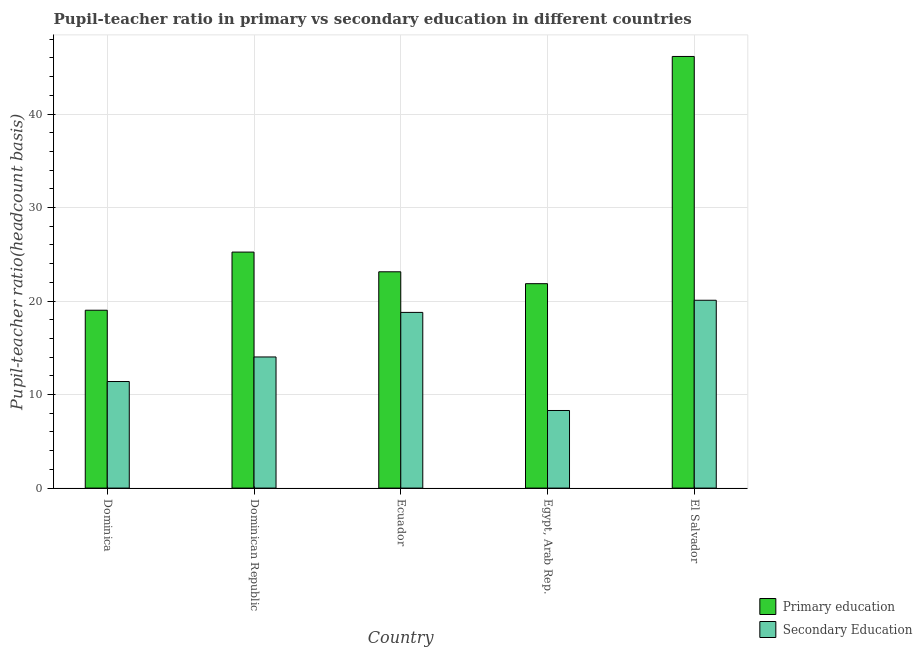How many groups of bars are there?
Provide a succinct answer. 5. Are the number of bars per tick equal to the number of legend labels?
Provide a short and direct response. Yes. How many bars are there on the 2nd tick from the left?
Ensure brevity in your answer.  2. How many bars are there on the 1st tick from the right?
Offer a very short reply. 2. What is the label of the 2nd group of bars from the left?
Provide a short and direct response. Dominican Republic. What is the pupil-teacher ratio in primary education in El Salvador?
Provide a short and direct response. 46.16. Across all countries, what is the maximum pupil-teacher ratio in primary education?
Offer a terse response. 46.16. Across all countries, what is the minimum pupil-teacher ratio in primary education?
Give a very brief answer. 19.02. In which country was the pupil-teacher ratio in primary education maximum?
Your answer should be compact. El Salvador. In which country was the pupil-teacher ratio in primary education minimum?
Ensure brevity in your answer.  Dominica. What is the total pupil teacher ratio on secondary education in the graph?
Give a very brief answer. 72.6. What is the difference between the pupil teacher ratio on secondary education in Dominica and that in El Salvador?
Make the answer very short. -8.69. What is the difference between the pupil teacher ratio on secondary education in Ecuador and the pupil-teacher ratio in primary education in Dominica?
Provide a succinct answer. -0.23. What is the average pupil teacher ratio on secondary education per country?
Make the answer very short. 14.52. What is the difference between the pupil teacher ratio on secondary education and pupil-teacher ratio in primary education in Dominican Republic?
Ensure brevity in your answer.  -11.21. In how many countries, is the pupil teacher ratio on secondary education greater than 40 ?
Offer a very short reply. 0. What is the ratio of the pupil teacher ratio on secondary education in Dominica to that in El Salvador?
Keep it short and to the point. 0.57. Is the pupil teacher ratio on secondary education in Egypt, Arab Rep. less than that in El Salvador?
Make the answer very short. Yes. Is the difference between the pupil teacher ratio on secondary education in Dominican Republic and Egypt, Arab Rep. greater than the difference between the pupil-teacher ratio in primary education in Dominican Republic and Egypt, Arab Rep.?
Ensure brevity in your answer.  Yes. What is the difference between the highest and the second highest pupil teacher ratio on secondary education?
Your answer should be very brief. 1.3. What is the difference between the highest and the lowest pupil teacher ratio on secondary education?
Give a very brief answer. 11.79. In how many countries, is the pupil teacher ratio on secondary education greater than the average pupil teacher ratio on secondary education taken over all countries?
Keep it short and to the point. 2. Is the sum of the pupil teacher ratio on secondary education in Dominican Republic and Egypt, Arab Rep. greater than the maximum pupil-teacher ratio in primary education across all countries?
Your response must be concise. No. What does the 2nd bar from the left in Ecuador represents?
Make the answer very short. Secondary Education. What does the 1st bar from the right in Dominica represents?
Your answer should be compact. Secondary Education. What is the difference between two consecutive major ticks on the Y-axis?
Make the answer very short. 10. Does the graph contain any zero values?
Your answer should be compact. No. Does the graph contain grids?
Provide a short and direct response. Yes. Where does the legend appear in the graph?
Your response must be concise. Bottom right. How many legend labels are there?
Offer a terse response. 2. How are the legend labels stacked?
Offer a terse response. Vertical. What is the title of the graph?
Your response must be concise. Pupil-teacher ratio in primary vs secondary education in different countries. What is the label or title of the X-axis?
Keep it short and to the point. Country. What is the label or title of the Y-axis?
Give a very brief answer. Pupil-teacher ratio(headcount basis). What is the Pupil-teacher ratio(headcount basis) of Primary education in Dominica?
Offer a terse response. 19.02. What is the Pupil-teacher ratio(headcount basis) of Secondary Education in Dominica?
Ensure brevity in your answer.  11.4. What is the Pupil-teacher ratio(headcount basis) of Primary education in Dominican Republic?
Offer a terse response. 25.24. What is the Pupil-teacher ratio(headcount basis) in Secondary Education in Dominican Republic?
Provide a short and direct response. 14.02. What is the Pupil-teacher ratio(headcount basis) of Primary education in Ecuador?
Keep it short and to the point. 23.13. What is the Pupil-teacher ratio(headcount basis) of Secondary Education in Ecuador?
Your answer should be compact. 18.79. What is the Pupil-teacher ratio(headcount basis) in Primary education in Egypt, Arab Rep.?
Your response must be concise. 21.86. What is the Pupil-teacher ratio(headcount basis) in Secondary Education in Egypt, Arab Rep.?
Provide a short and direct response. 8.3. What is the Pupil-teacher ratio(headcount basis) in Primary education in El Salvador?
Your answer should be compact. 46.16. What is the Pupil-teacher ratio(headcount basis) in Secondary Education in El Salvador?
Provide a succinct answer. 20.09. Across all countries, what is the maximum Pupil-teacher ratio(headcount basis) of Primary education?
Keep it short and to the point. 46.16. Across all countries, what is the maximum Pupil-teacher ratio(headcount basis) of Secondary Education?
Ensure brevity in your answer.  20.09. Across all countries, what is the minimum Pupil-teacher ratio(headcount basis) in Primary education?
Provide a succinct answer. 19.02. Across all countries, what is the minimum Pupil-teacher ratio(headcount basis) of Secondary Education?
Provide a succinct answer. 8.3. What is the total Pupil-teacher ratio(headcount basis) in Primary education in the graph?
Your response must be concise. 135.41. What is the total Pupil-teacher ratio(headcount basis) of Secondary Education in the graph?
Your response must be concise. 72.6. What is the difference between the Pupil-teacher ratio(headcount basis) in Primary education in Dominica and that in Dominican Republic?
Provide a short and direct response. -6.22. What is the difference between the Pupil-teacher ratio(headcount basis) of Secondary Education in Dominica and that in Dominican Republic?
Provide a succinct answer. -2.63. What is the difference between the Pupil-teacher ratio(headcount basis) in Primary education in Dominica and that in Ecuador?
Keep it short and to the point. -4.11. What is the difference between the Pupil-teacher ratio(headcount basis) of Secondary Education in Dominica and that in Ecuador?
Give a very brief answer. -7.39. What is the difference between the Pupil-teacher ratio(headcount basis) of Primary education in Dominica and that in Egypt, Arab Rep.?
Provide a short and direct response. -2.84. What is the difference between the Pupil-teacher ratio(headcount basis) of Secondary Education in Dominica and that in Egypt, Arab Rep.?
Give a very brief answer. 3.1. What is the difference between the Pupil-teacher ratio(headcount basis) of Primary education in Dominica and that in El Salvador?
Your answer should be compact. -27.14. What is the difference between the Pupil-teacher ratio(headcount basis) of Secondary Education in Dominica and that in El Salvador?
Your answer should be very brief. -8.69. What is the difference between the Pupil-teacher ratio(headcount basis) of Primary education in Dominican Republic and that in Ecuador?
Make the answer very short. 2.11. What is the difference between the Pupil-teacher ratio(headcount basis) of Secondary Education in Dominican Republic and that in Ecuador?
Provide a succinct answer. -4.77. What is the difference between the Pupil-teacher ratio(headcount basis) in Primary education in Dominican Republic and that in Egypt, Arab Rep.?
Keep it short and to the point. 3.38. What is the difference between the Pupil-teacher ratio(headcount basis) in Secondary Education in Dominican Republic and that in Egypt, Arab Rep.?
Your response must be concise. 5.73. What is the difference between the Pupil-teacher ratio(headcount basis) in Primary education in Dominican Republic and that in El Salvador?
Ensure brevity in your answer.  -20.92. What is the difference between the Pupil-teacher ratio(headcount basis) in Secondary Education in Dominican Republic and that in El Salvador?
Offer a terse response. -6.06. What is the difference between the Pupil-teacher ratio(headcount basis) in Primary education in Ecuador and that in Egypt, Arab Rep.?
Make the answer very short. 1.27. What is the difference between the Pupil-teacher ratio(headcount basis) in Secondary Education in Ecuador and that in Egypt, Arab Rep.?
Give a very brief answer. 10.49. What is the difference between the Pupil-teacher ratio(headcount basis) of Primary education in Ecuador and that in El Salvador?
Ensure brevity in your answer.  -23.03. What is the difference between the Pupil-teacher ratio(headcount basis) in Secondary Education in Ecuador and that in El Salvador?
Keep it short and to the point. -1.3. What is the difference between the Pupil-teacher ratio(headcount basis) of Primary education in Egypt, Arab Rep. and that in El Salvador?
Keep it short and to the point. -24.3. What is the difference between the Pupil-teacher ratio(headcount basis) of Secondary Education in Egypt, Arab Rep. and that in El Salvador?
Provide a succinct answer. -11.79. What is the difference between the Pupil-teacher ratio(headcount basis) of Primary education in Dominica and the Pupil-teacher ratio(headcount basis) of Secondary Education in Dominican Republic?
Give a very brief answer. 5. What is the difference between the Pupil-teacher ratio(headcount basis) in Primary education in Dominica and the Pupil-teacher ratio(headcount basis) in Secondary Education in Ecuador?
Ensure brevity in your answer.  0.23. What is the difference between the Pupil-teacher ratio(headcount basis) in Primary education in Dominica and the Pupil-teacher ratio(headcount basis) in Secondary Education in Egypt, Arab Rep.?
Your answer should be compact. 10.72. What is the difference between the Pupil-teacher ratio(headcount basis) of Primary education in Dominica and the Pupil-teacher ratio(headcount basis) of Secondary Education in El Salvador?
Provide a succinct answer. -1.07. What is the difference between the Pupil-teacher ratio(headcount basis) in Primary education in Dominican Republic and the Pupil-teacher ratio(headcount basis) in Secondary Education in Ecuador?
Provide a succinct answer. 6.45. What is the difference between the Pupil-teacher ratio(headcount basis) in Primary education in Dominican Republic and the Pupil-teacher ratio(headcount basis) in Secondary Education in Egypt, Arab Rep.?
Your response must be concise. 16.94. What is the difference between the Pupil-teacher ratio(headcount basis) in Primary education in Dominican Republic and the Pupil-teacher ratio(headcount basis) in Secondary Education in El Salvador?
Make the answer very short. 5.15. What is the difference between the Pupil-teacher ratio(headcount basis) in Primary education in Ecuador and the Pupil-teacher ratio(headcount basis) in Secondary Education in Egypt, Arab Rep.?
Make the answer very short. 14.83. What is the difference between the Pupil-teacher ratio(headcount basis) in Primary education in Ecuador and the Pupil-teacher ratio(headcount basis) in Secondary Education in El Salvador?
Your answer should be very brief. 3.04. What is the difference between the Pupil-teacher ratio(headcount basis) in Primary education in Egypt, Arab Rep. and the Pupil-teacher ratio(headcount basis) in Secondary Education in El Salvador?
Give a very brief answer. 1.77. What is the average Pupil-teacher ratio(headcount basis) of Primary education per country?
Offer a terse response. 27.08. What is the average Pupil-teacher ratio(headcount basis) of Secondary Education per country?
Your answer should be very brief. 14.52. What is the difference between the Pupil-teacher ratio(headcount basis) of Primary education and Pupil-teacher ratio(headcount basis) of Secondary Education in Dominica?
Provide a short and direct response. 7.62. What is the difference between the Pupil-teacher ratio(headcount basis) in Primary education and Pupil-teacher ratio(headcount basis) in Secondary Education in Dominican Republic?
Ensure brevity in your answer.  11.21. What is the difference between the Pupil-teacher ratio(headcount basis) of Primary education and Pupil-teacher ratio(headcount basis) of Secondary Education in Ecuador?
Provide a short and direct response. 4.34. What is the difference between the Pupil-teacher ratio(headcount basis) in Primary education and Pupil-teacher ratio(headcount basis) in Secondary Education in Egypt, Arab Rep.?
Your answer should be compact. 13.56. What is the difference between the Pupil-teacher ratio(headcount basis) in Primary education and Pupil-teacher ratio(headcount basis) in Secondary Education in El Salvador?
Offer a very short reply. 26.07. What is the ratio of the Pupil-teacher ratio(headcount basis) of Primary education in Dominica to that in Dominican Republic?
Provide a short and direct response. 0.75. What is the ratio of the Pupil-teacher ratio(headcount basis) in Secondary Education in Dominica to that in Dominican Republic?
Keep it short and to the point. 0.81. What is the ratio of the Pupil-teacher ratio(headcount basis) in Primary education in Dominica to that in Ecuador?
Offer a terse response. 0.82. What is the ratio of the Pupil-teacher ratio(headcount basis) in Secondary Education in Dominica to that in Ecuador?
Provide a succinct answer. 0.61. What is the ratio of the Pupil-teacher ratio(headcount basis) in Primary education in Dominica to that in Egypt, Arab Rep.?
Keep it short and to the point. 0.87. What is the ratio of the Pupil-teacher ratio(headcount basis) of Secondary Education in Dominica to that in Egypt, Arab Rep.?
Provide a succinct answer. 1.37. What is the ratio of the Pupil-teacher ratio(headcount basis) of Primary education in Dominica to that in El Salvador?
Provide a succinct answer. 0.41. What is the ratio of the Pupil-teacher ratio(headcount basis) of Secondary Education in Dominica to that in El Salvador?
Your answer should be compact. 0.57. What is the ratio of the Pupil-teacher ratio(headcount basis) of Primary education in Dominican Republic to that in Ecuador?
Offer a terse response. 1.09. What is the ratio of the Pupil-teacher ratio(headcount basis) in Secondary Education in Dominican Republic to that in Ecuador?
Your answer should be very brief. 0.75. What is the ratio of the Pupil-teacher ratio(headcount basis) in Primary education in Dominican Republic to that in Egypt, Arab Rep.?
Offer a terse response. 1.15. What is the ratio of the Pupil-teacher ratio(headcount basis) of Secondary Education in Dominican Republic to that in Egypt, Arab Rep.?
Your response must be concise. 1.69. What is the ratio of the Pupil-teacher ratio(headcount basis) in Primary education in Dominican Republic to that in El Salvador?
Offer a very short reply. 0.55. What is the ratio of the Pupil-teacher ratio(headcount basis) of Secondary Education in Dominican Republic to that in El Salvador?
Give a very brief answer. 0.7. What is the ratio of the Pupil-teacher ratio(headcount basis) in Primary education in Ecuador to that in Egypt, Arab Rep.?
Provide a short and direct response. 1.06. What is the ratio of the Pupil-teacher ratio(headcount basis) of Secondary Education in Ecuador to that in Egypt, Arab Rep.?
Keep it short and to the point. 2.26. What is the ratio of the Pupil-teacher ratio(headcount basis) in Primary education in Ecuador to that in El Salvador?
Provide a short and direct response. 0.5. What is the ratio of the Pupil-teacher ratio(headcount basis) in Secondary Education in Ecuador to that in El Salvador?
Make the answer very short. 0.94. What is the ratio of the Pupil-teacher ratio(headcount basis) in Primary education in Egypt, Arab Rep. to that in El Salvador?
Provide a short and direct response. 0.47. What is the ratio of the Pupil-teacher ratio(headcount basis) of Secondary Education in Egypt, Arab Rep. to that in El Salvador?
Provide a succinct answer. 0.41. What is the difference between the highest and the second highest Pupil-teacher ratio(headcount basis) in Primary education?
Offer a very short reply. 20.92. What is the difference between the highest and the second highest Pupil-teacher ratio(headcount basis) of Secondary Education?
Offer a terse response. 1.3. What is the difference between the highest and the lowest Pupil-teacher ratio(headcount basis) of Primary education?
Provide a short and direct response. 27.14. What is the difference between the highest and the lowest Pupil-teacher ratio(headcount basis) in Secondary Education?
Your response must be concise. 11.79. 